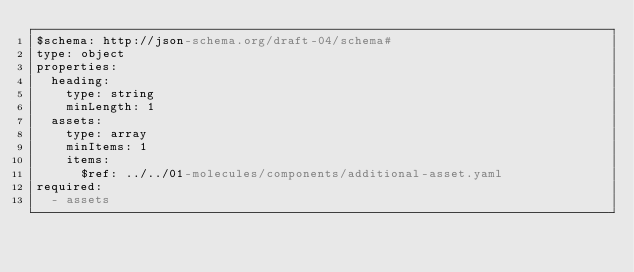Convert code to text. <code><loc_0><loc_0><loc_500><loc_500><_YAML_>$schema: http://json-schema.org/draft-04/schema#
type: object
properties:
  heading:
    type: string
    minLength: 1
  assets:
    type: array
    minItems: 1
    items:
      $ref: ../../01-molecules/components/additional-asset.yaml
required:
  - assets
</code> 